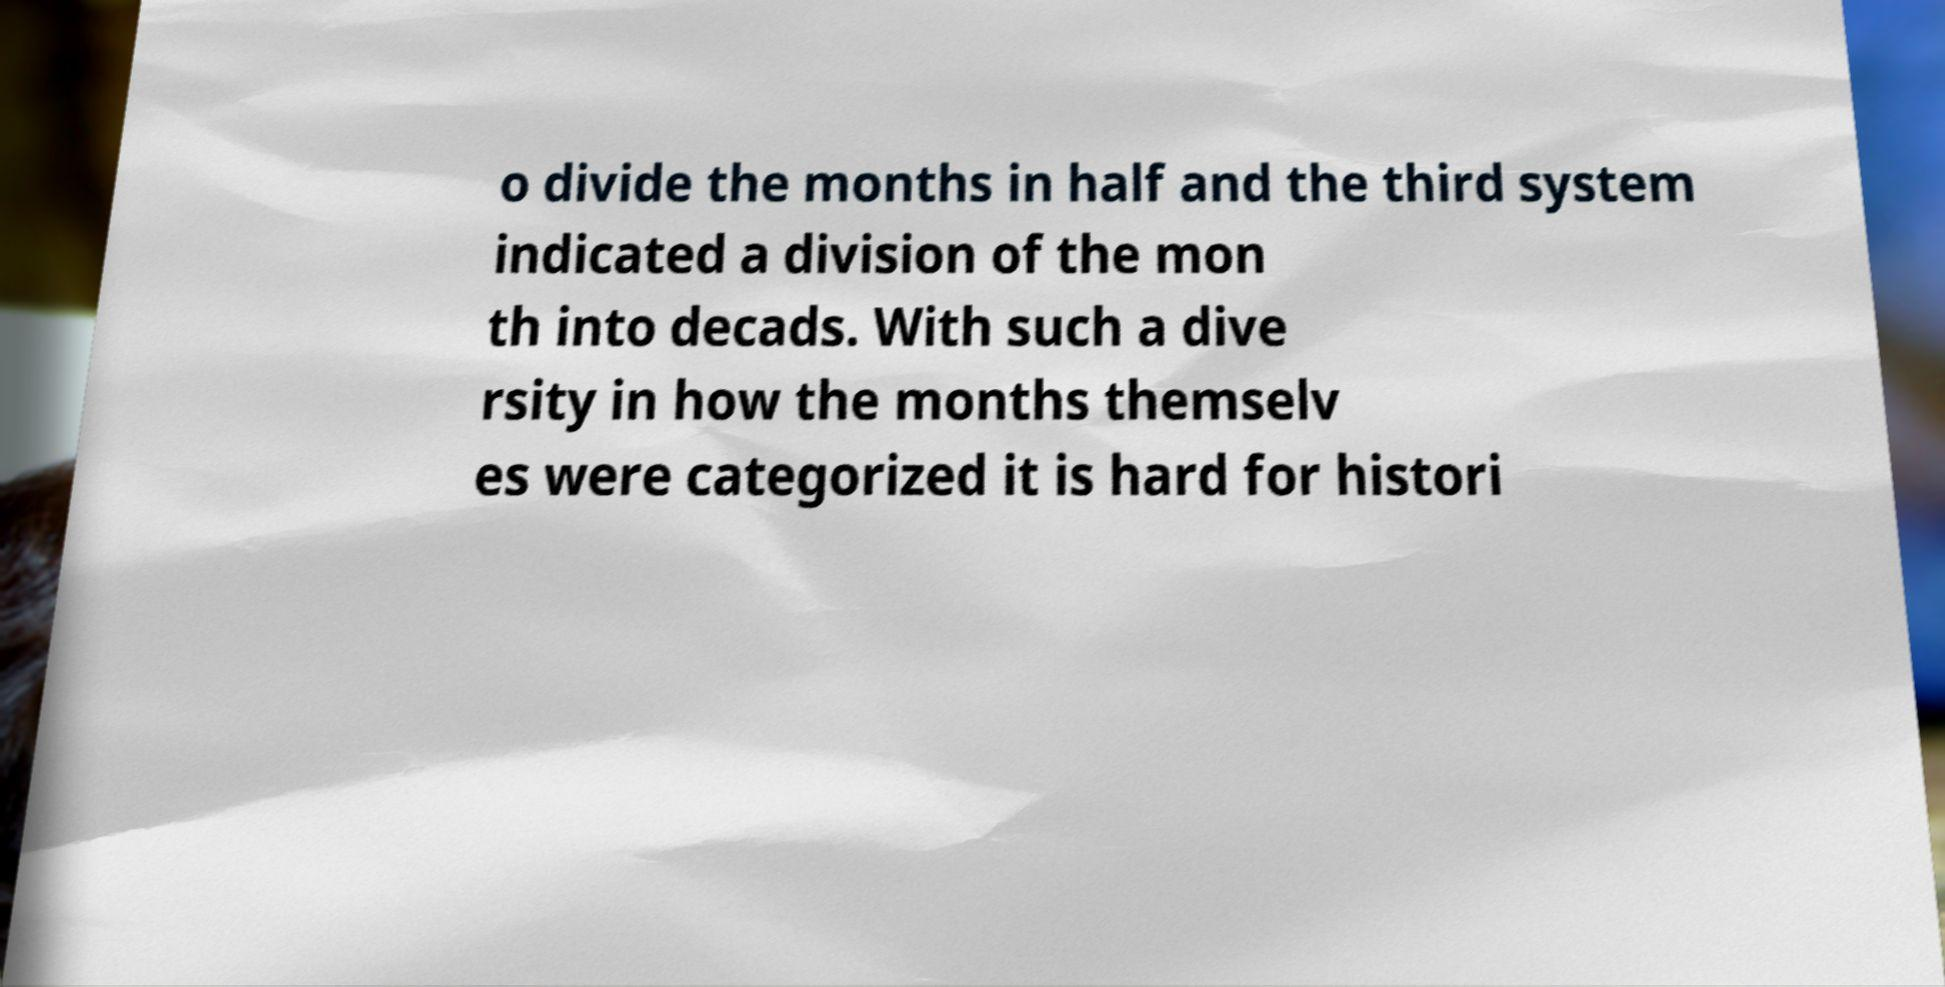For documentation purposes, I need the text within this image transcribed. Could you provide that? o divide the months in half and the third system indicated a division of the mon th into decads. With such a dive rsity in how the months themselv es were categorized it is hard for histori 